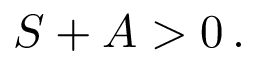Convert formula to latex. <formula><loc_0><loc_0><loc_500><loc_500>S + A > 0 \, .</formula> 